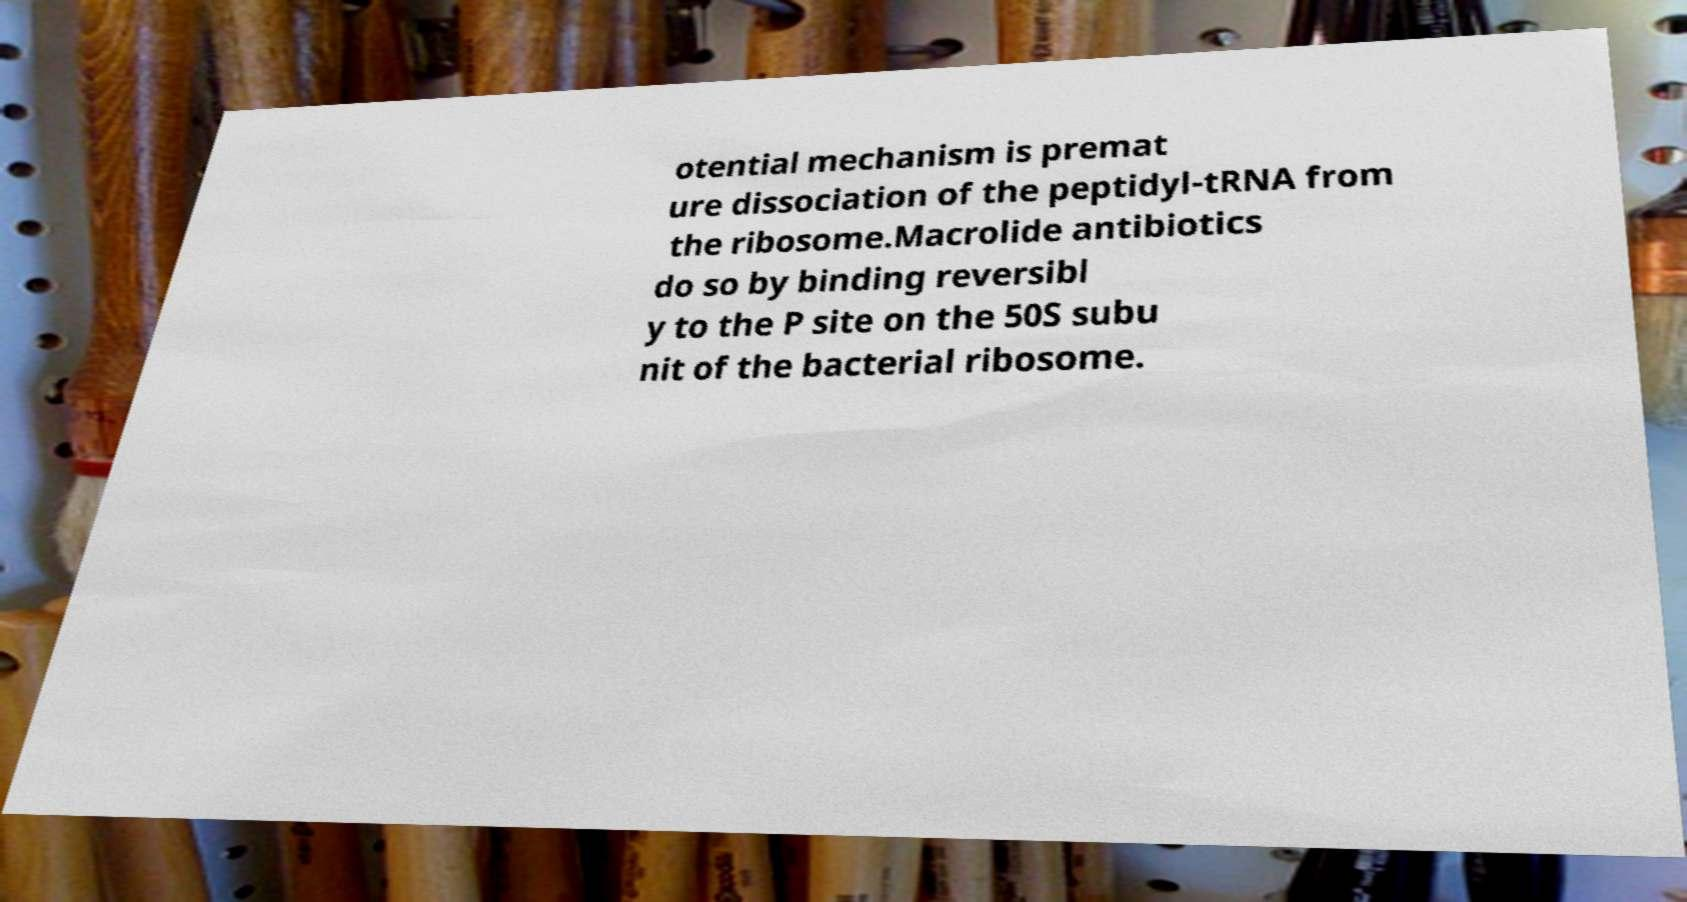Can you read and provide the text displayed in the image?This photo seems to have some interesting text. Can you extract and type it out for me? otential mechanism is premat ure dissociation of the peptidyl-tRNA from the ribosome.Macrolide antibiotics do so by binding reversibl y to the P site on the 50S subu nit of the bacterial ribosome. 